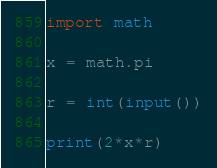<code> <loc_0><loc_0><loc_500><loc_500><_Python_>import math

x = math.pi

r = int(input())

print(2*x*r)</code> 